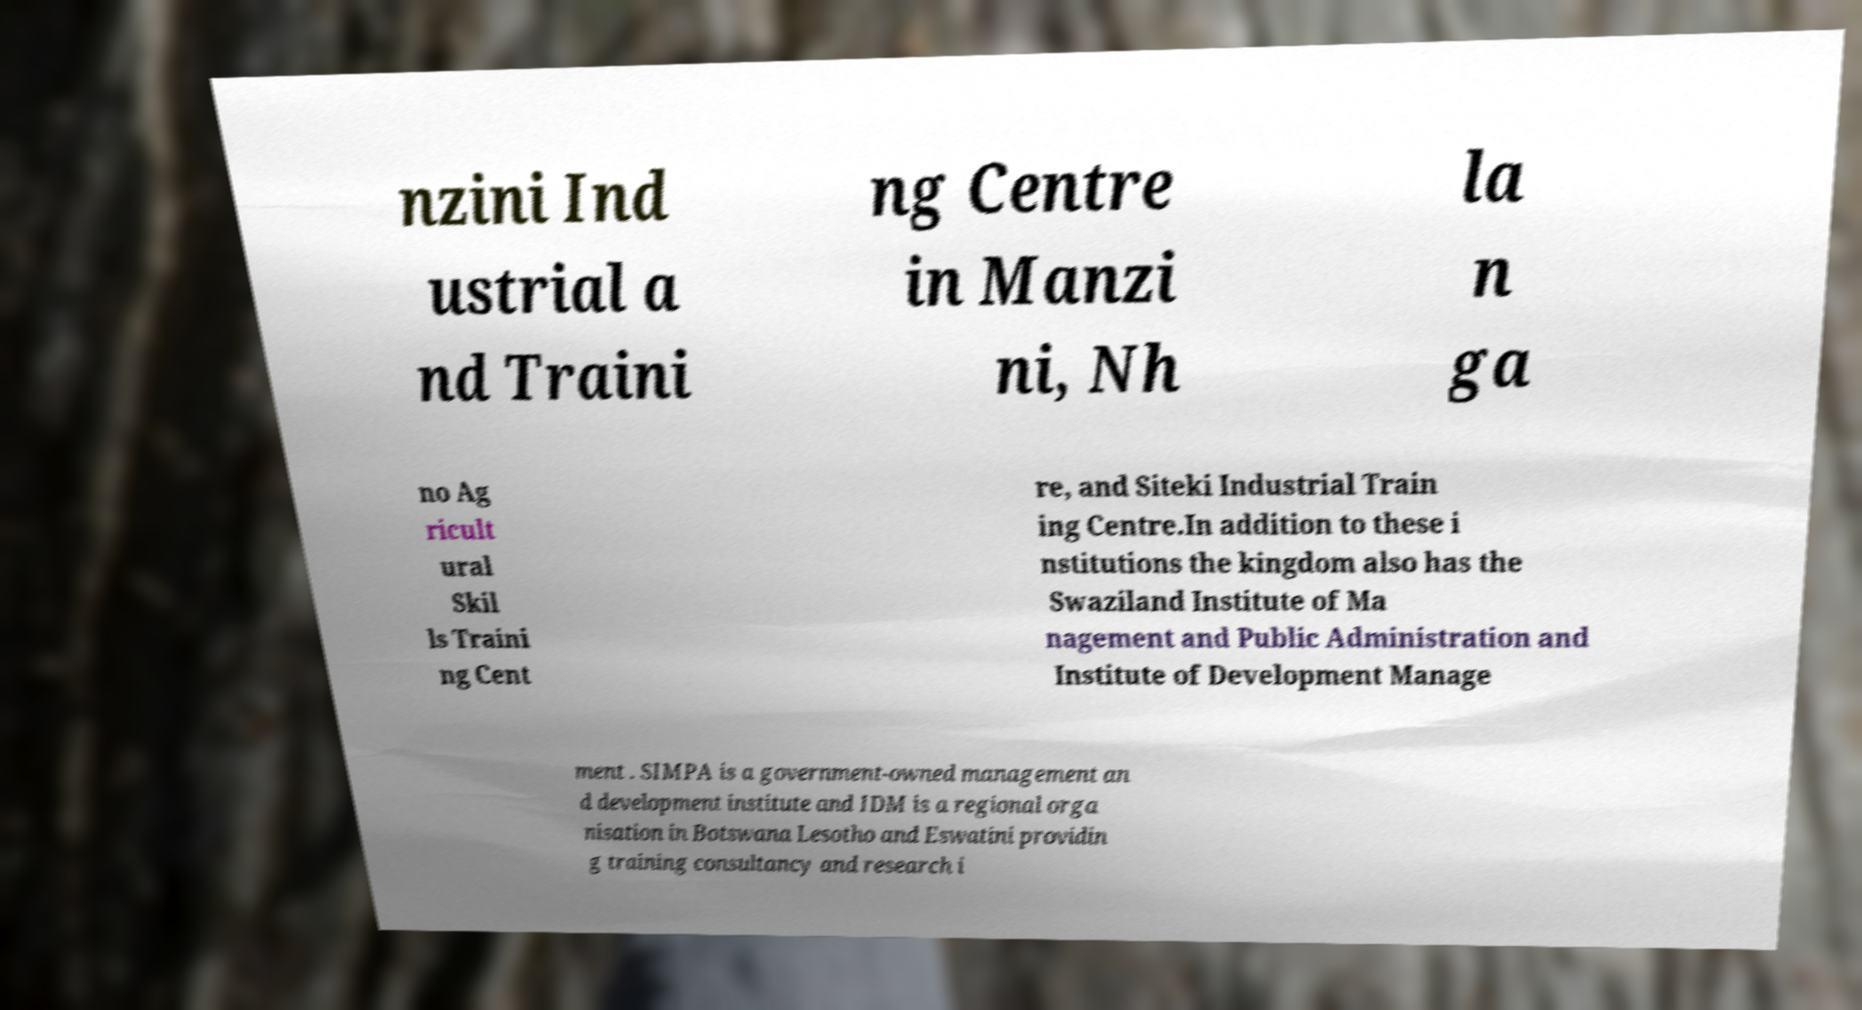There's text embedded in this image that I need extracted. Can you transcribe it verbatim? nzini Ind ustrial a nd Traini ng Centre in Manzi ni, Nh la n ga no Ag ricult ural Skil ls Traini ng Cent re, and Siteki Industrial Train ing Centre.In addition to these i nstitutions the kingdom also has the Swaziland Institute of Ma nagement and Public Administration and Institute of Development Manage ment . SIMPA is a government-owned management an d development institute and IDM is a regional orga nisation in Botswana Lesotho and Eswatini providin g training consultancy and research i 